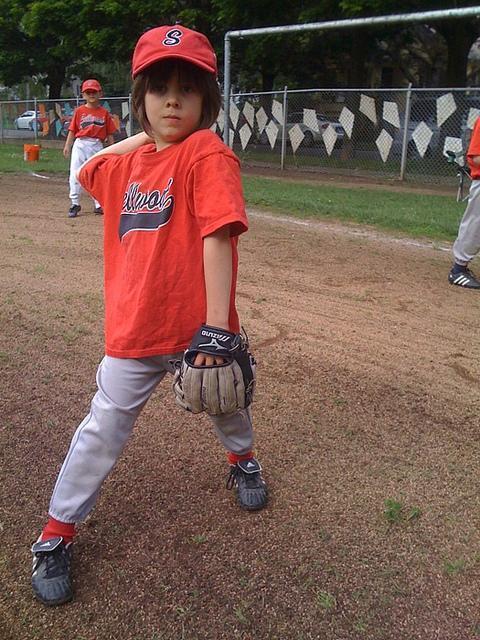How many people can be seen?
Give a very brief answer. 3. 